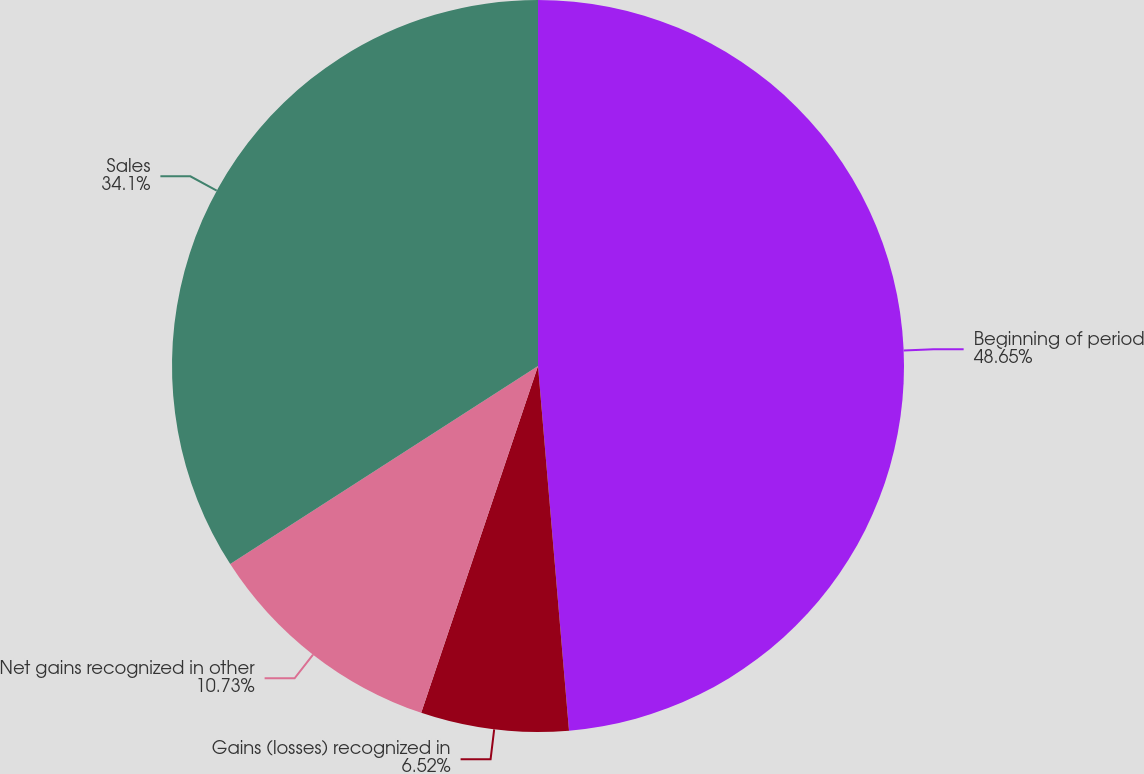Convert chart. <chart><loc_0><loc_0><loc_500><loc_500><pie_chart><fcel>Beginning of period<fcel>Gains (losses) recognized in<fcel>Net gains recognized in other<fcel>Sales<nl><fcel>48.65%<fcel>6.52%<fcel>10.73%<fcel>34.1%<nl></chart> 